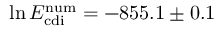<formula> <loc_0><loc_0><loc_500><loc_500>\ln E _ { c d i } ^ { n u m } = - 8 5 5 . 1 \pm 0 . 1</formula> 